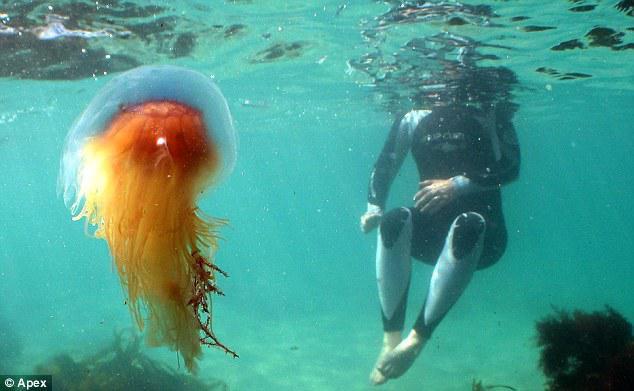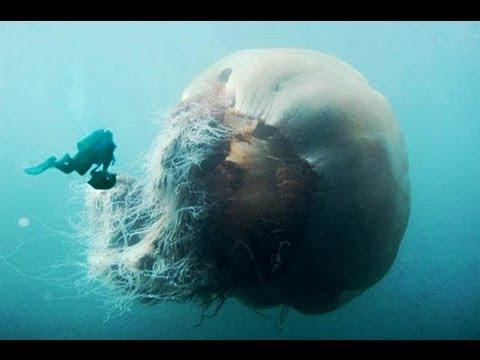The first image is the image on the left, the second image is the image on the right. Considering the images on both sides, is "There is at least one person without an airtank." valid? Answer yes or no. Yes. The first image is the image on the left, the second image is the image on the right. For the images displayed, is the sentence "Each image includes a person wearing a scuba-type wetsuit." factually correct? Answer yes or no. Yes. 